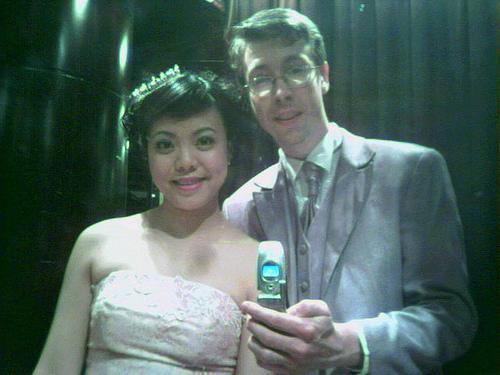What is the man using the phone to do?
Select the accurate answer and provide explanation: 'Answer: answer
Rationale: rationale.'
Options: Play games, take picture, make call, text. Answer: take picture.
Rationale: The phone has a camera feature visible and the people are posing which would be consistent with their intention to do answer a. 